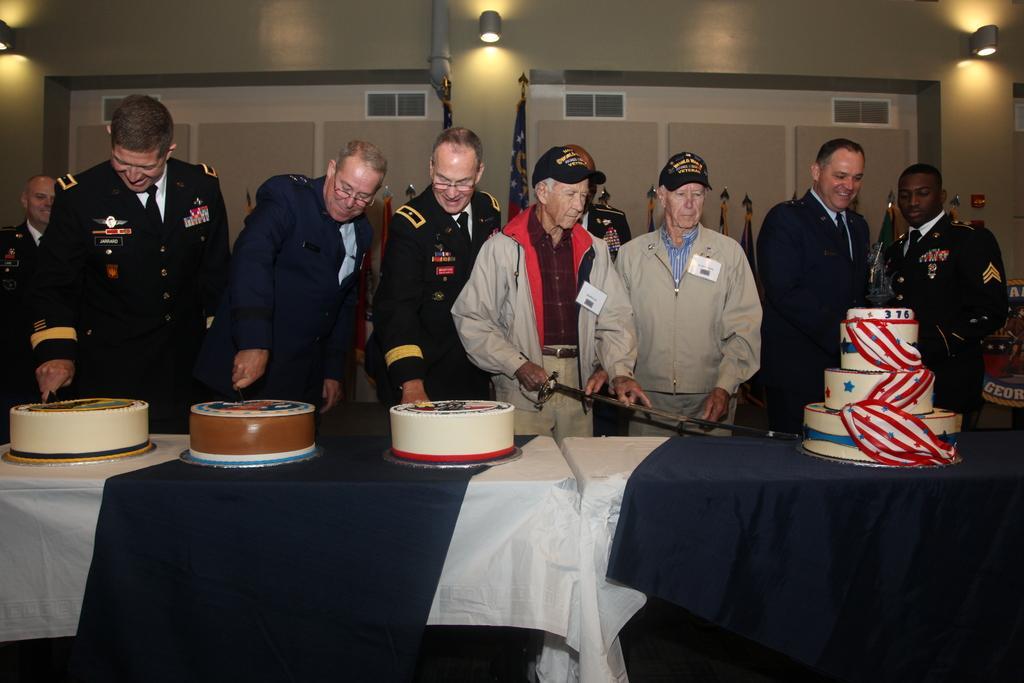In one or two sentences, can you explain what this image depicts? In the image we can see there are many men standing, wearing clothes and some of them are wearing spectacles and they are laughing. In front of them there is a table, on the table there are cakes of different colors. This is a sword, white and blue color cloth, lights and a flag. 